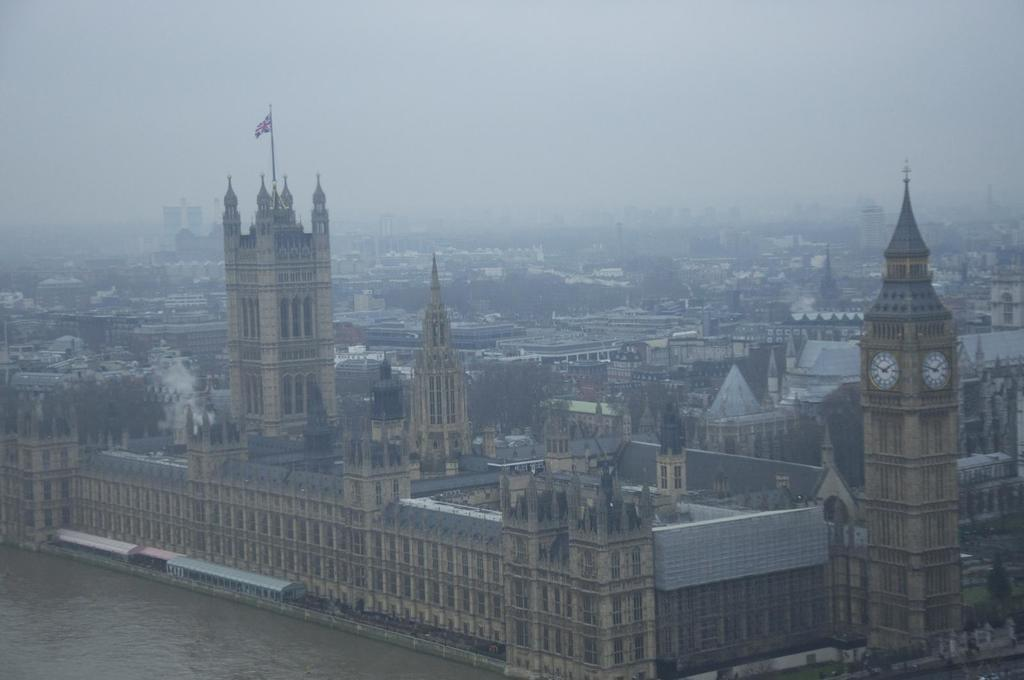What type of view is shown in the image? The image is a top view of a city. How would you describe the overall appearance of the image? The image is smoky. What structures can be seen in the image? There are buildings, towers, and a train in the image. Are there any natural elements present in the image? Yes, there are trees and a lake in the image. What part of the natural environment is visible in the image? The sky is visible at the top of the image. How does the beginner learn to use the spoon in the image? There is no spoon present in the image, and therefore no learning process related to it. What type of mint is growing near the lake in the image? There is no mint present in the image, and the image does not show any plants near the lake. 